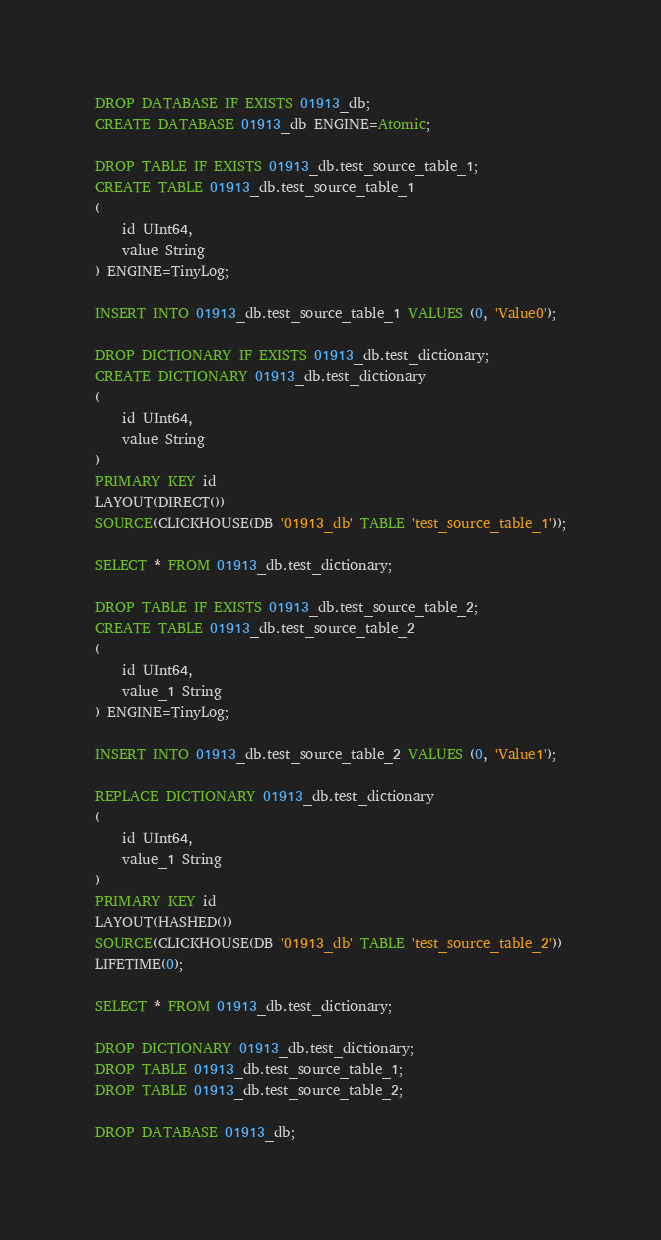<code> <loc_0><loc_0><loc_500><loc_500><_SQL_>DROP DATABASE IF EXISTS 01913_db;
CREATE DATABASE 01913_db ENGINE=Atomic;

DROP TABLE IF EXISTS 01913_db.test_source_table_1;
CREATE TABLE 01913_db.test_source_table_1
(
    id UInt64,
    value String
) ENGINE=TinyLog;

INSERT INTO 01913_db.test_source_table_1 VALUES (0, 'Value0');

DROP DICTIONARY IF EXISTS 01913_db.test_dictionary;
CREATE DICTIONARY 01913_db.test_dictionary
(
    id UInt64,
    value String
)
PRIMARY KEY id
LAYOUT(DIRECT())
SOURCE(CLICKHOUSE(DB '01913_db' TABLE 'test_source_table_1'));

SELECT * FROM 01913_db.test_dictionary;

DROP TABLE IF EXISTS 01913_db.test_source_table_2;
CREATE TABLE 01913_db.test_source_table_2
(
    id UInt64,
    value_1 String
) ENGINE=TinyLog;

INSERT INTO 01913_db.test_source_table_2 VALUES (0, 'Value1');

REPLACE DICTIONARY 01913_db.test_dictionary
(
    id UInt64,
    value_1 String
)
PRIMARY KEY id
LAYOUT(HASHED())
SOURCE(CLICKHOUSE(DB '01913_db' TABLE 'test_source_table_2'))
LIFETIME(0);

SELECT * FROM 01913_db.test_dictionary;

DROP DICTIONARY 01913_db.test_dictionary;
DROP TABLE 01913_db.test_source_table_1;
DROP TABLE 01913_db.test_source_table_2;

DROP DATABASE 01913_db;
</code> 